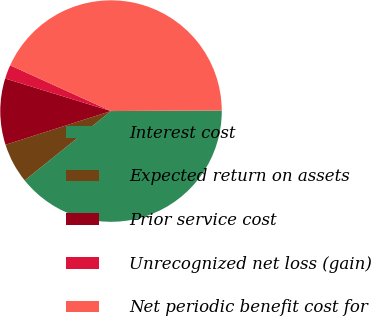Convert chart to OTSL. <chart><loc_0><loc_0><loc_500><loc_500><pie_chart><fcel>Interest cost<fcel>Expected return on assets<fcel>Prior service cost<fcel>Unrecognized net loss (gain)<fcel>Net periodic benefit cost for<nl><fcel>39.31%<fcel>5.85%<fcel>9.67%<fcel>2.03%<fcel>43.13%<nl></chart> 